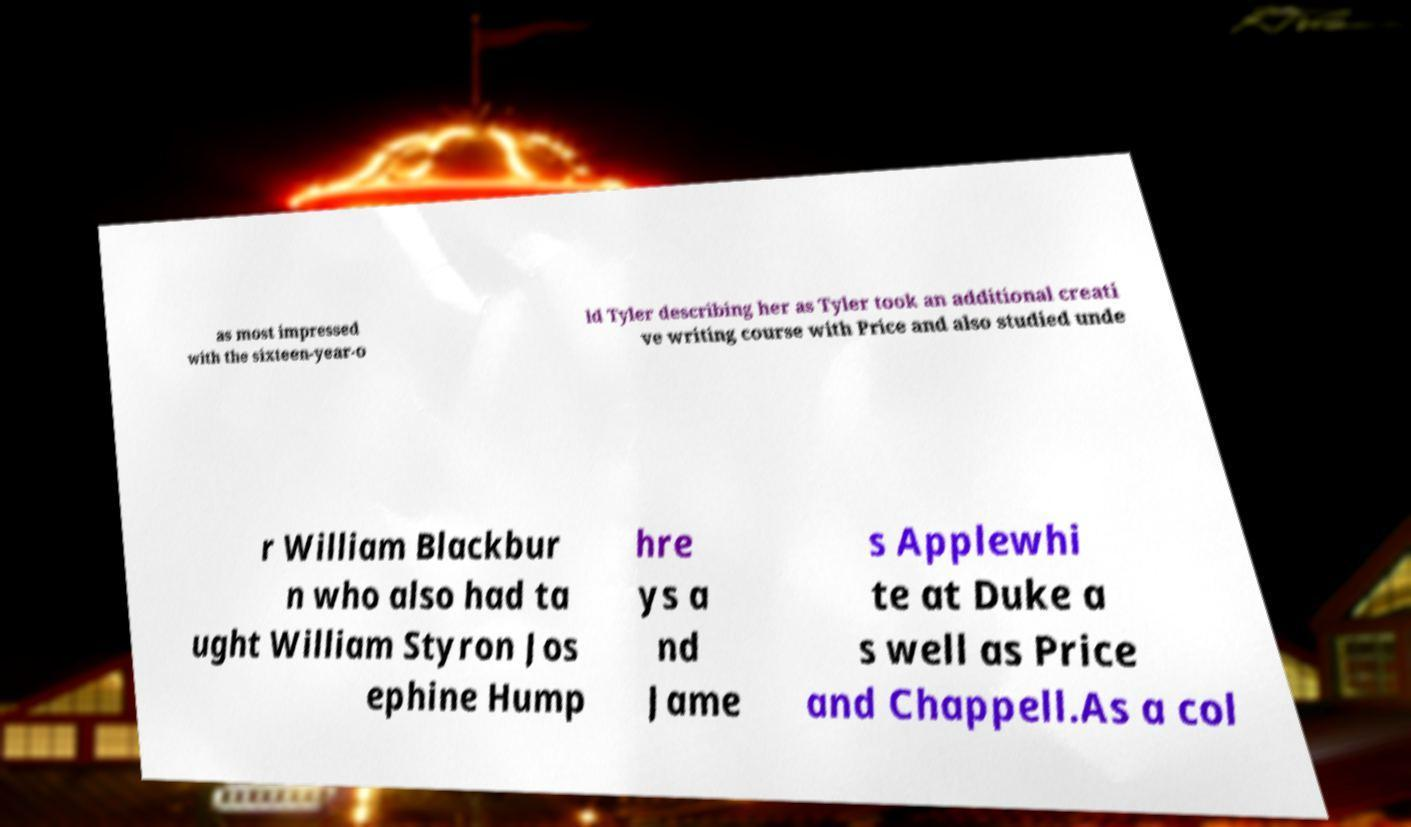Please identify and transcribe the text found in this image. as most impressed with the sixteen-year-o ld Tyler describing her as Tyler took an additional creati ve writing course with Price and also studied unde r William Blackbur n who also had ta ught William Styron Jos ephine Hump hre ys a nd Jame s Applewhi te at Duke a s well as Price and Chappell.As a col 